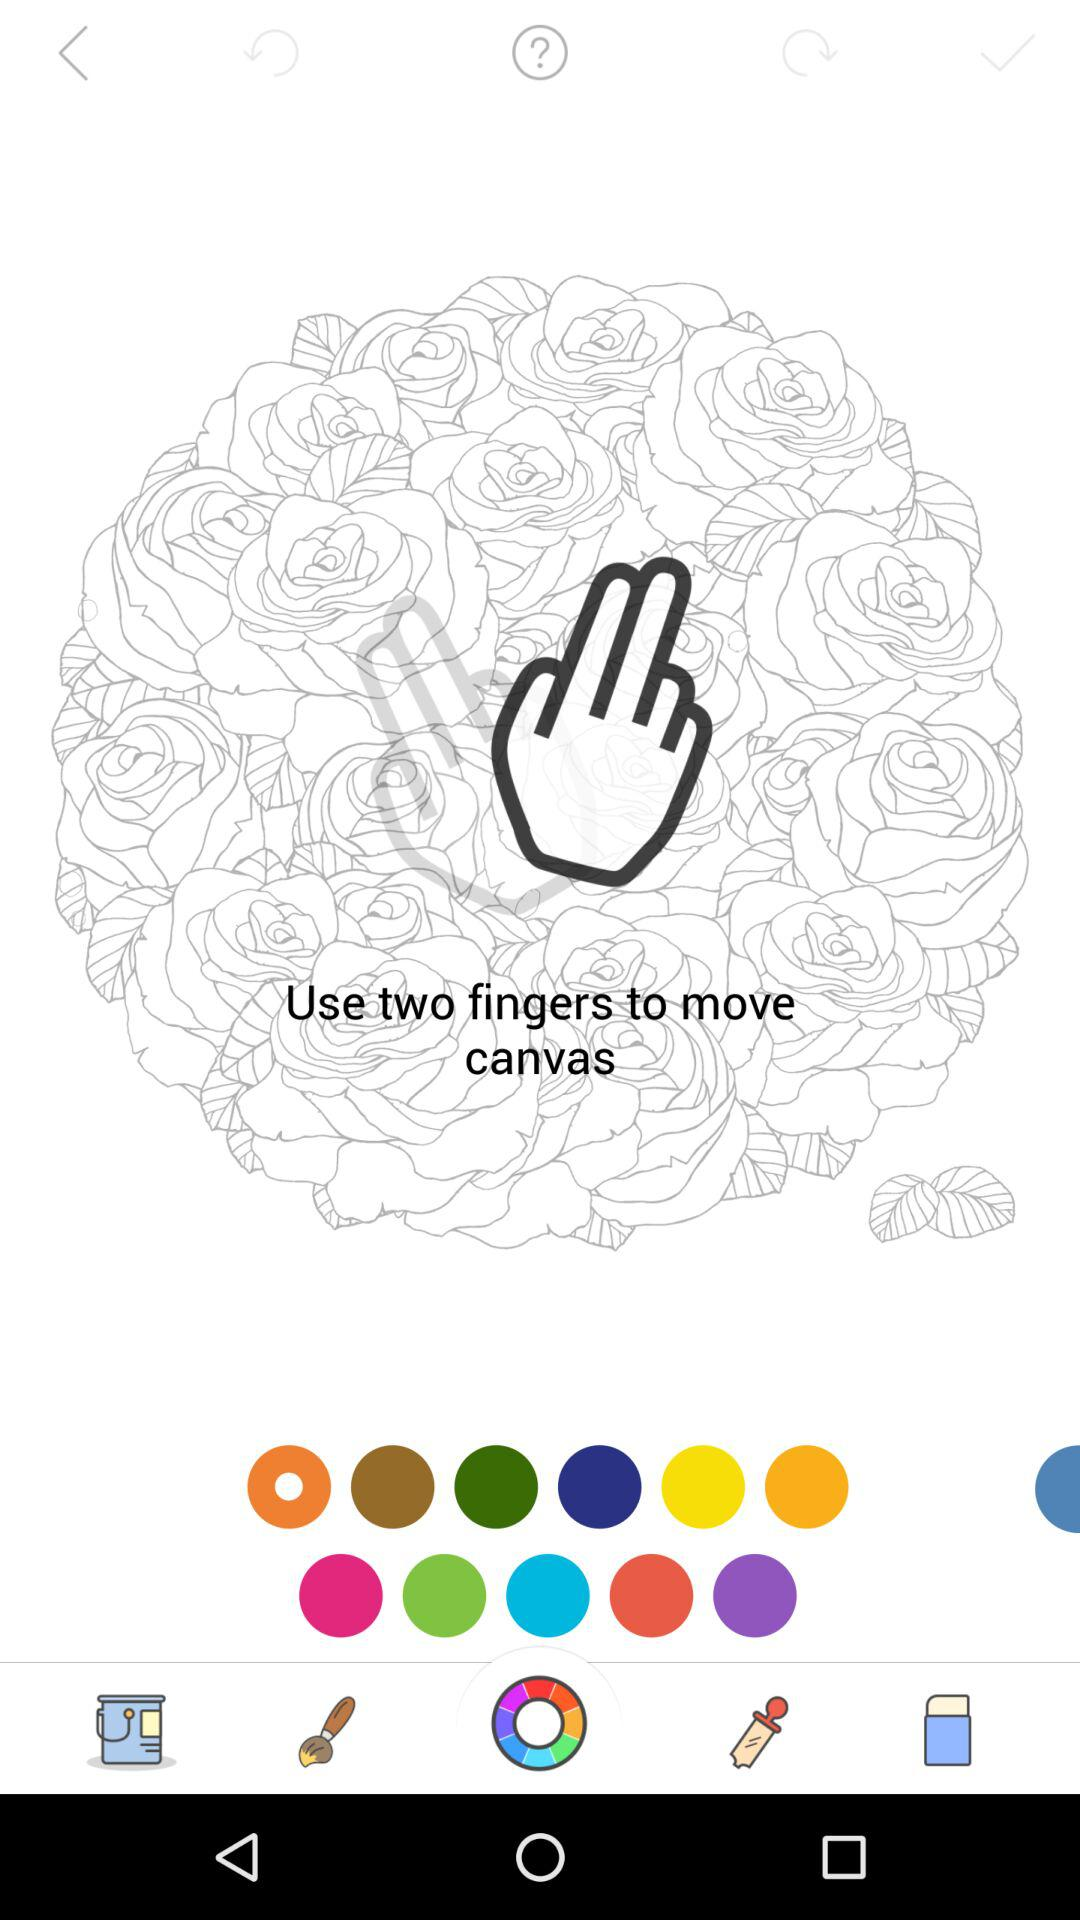How many tickets are required to unlock the image? There are 10 tickets required to unlock the image. 